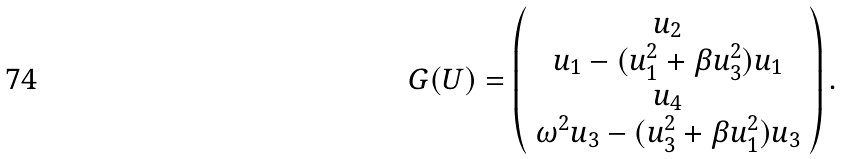<formula> <loc_0><loc_0><loc_500><loc_500>G ( U ) = \left ( \begin{array} { c } u _ { 2 } \\ u _ { 1 } - ( u _ { 1 } ^ { 2 } + \beta u _ { 3 } ^ { 2 } ) u _ { 1 } \\ u _ { 4 } \\ \omega ^ { 2 } u _ { 3 } - ( u _ { 3 } ^ { 2 } + \beta u _ { 1 } ^ { 2 } ) u _ { 3 } \end{array} \right ) .</formula> 